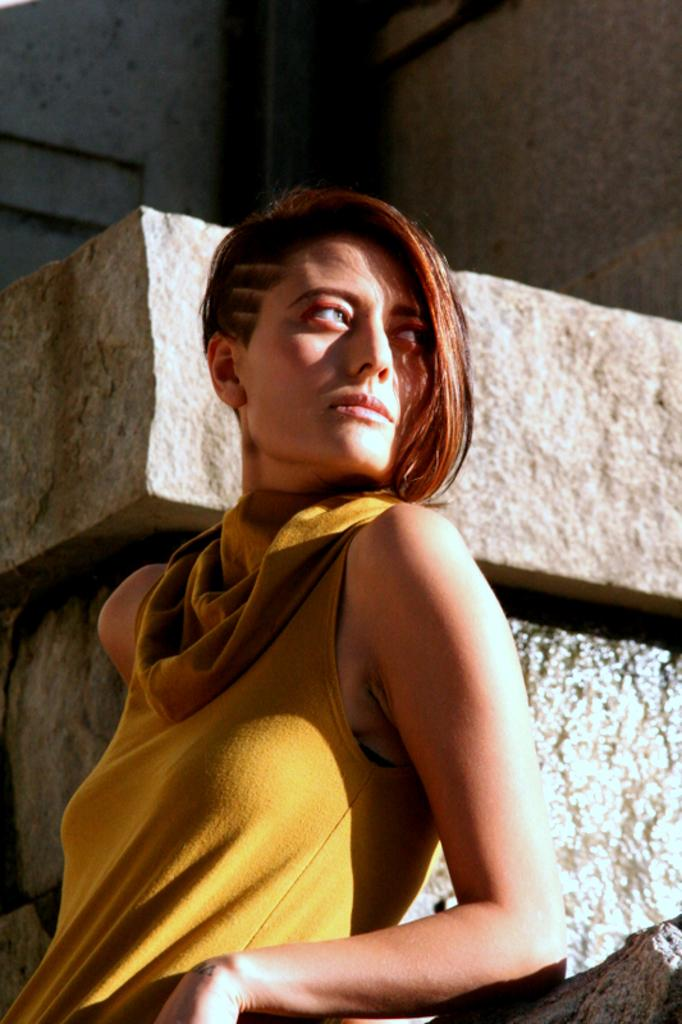What is the main subject in the foreground of the image? There is a woman in the foreground of the image. What type of natural elements can be seen in the background of the image? There are stones visible in the background of the image. What type of bone can be seen in the woman's hand in the image? There is no bone visible in the woman's hand or anywhere else in the image. 